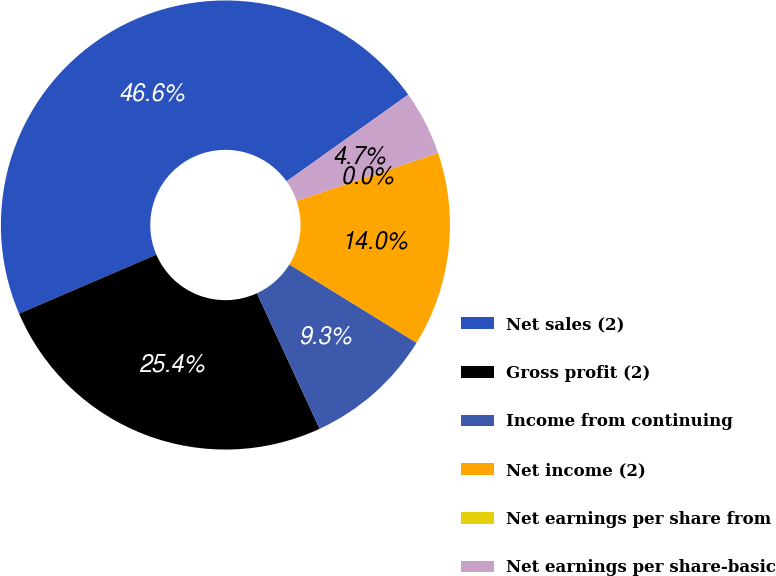Convert chart. <chart><loc_0><loc_0><loc_500><loc_500><pie_chart><fcel>Net sales (2)<fcel>Gross profit (2)<fcel>Income from continuing<fcel>Net income (2)<fcel>Net earnings per share from<fcel>Net earnings per share-basic<nl><fcel>46.6%<fcel>25.43%<fcel>9.32%<fcel>13.98%<fcel>0.0%<fcel>4.66%<nl></chart> 